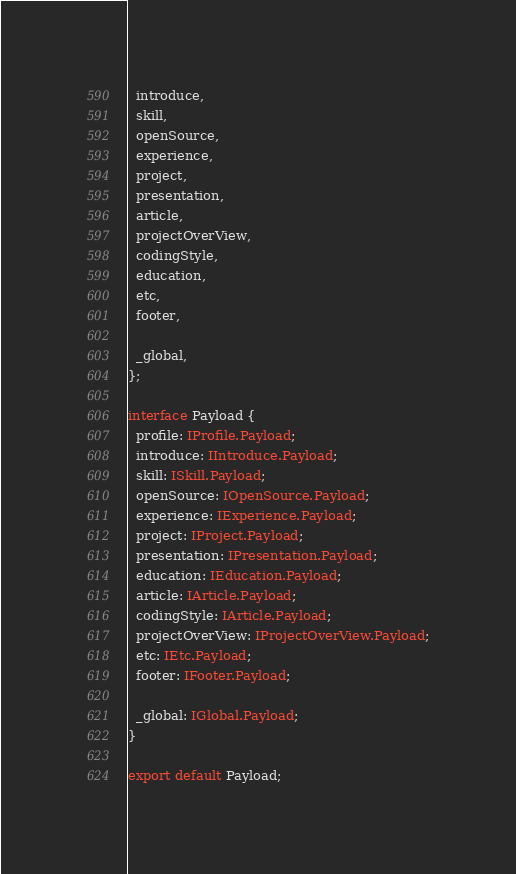Convert code to text. <code><loc_0><loc_0><loc_500><loc_500><_TypeScript_>  introduce,
  skill,
  openSource,
  experience,
  project,
  presentation,
  article,
  projectOverView,
  codingStyle,
  education,
  etc,
  footer,

  _global,
};

interface Payload {
  profile: IProfile.Payload;
  introduce: IIntroduce.Payload;
  skill: ISkill.Payload;
  openSource: IOpenSource.Payload;
  experience: IExperience.Payload;
  project: IProject.Payload;
  presentation: IPresentation.Payload;
  education: IEducation.Payload;
  article: IArticle.Payload;
  codingStyle: IArticle.Payload;
  projectOverView: IProjectOverView.Payload;
  etc: IEtc.Payload;
  footer: IFooter.Payload;

  _global: IGlobal.Payload;
}

export default Payload;
</code> 